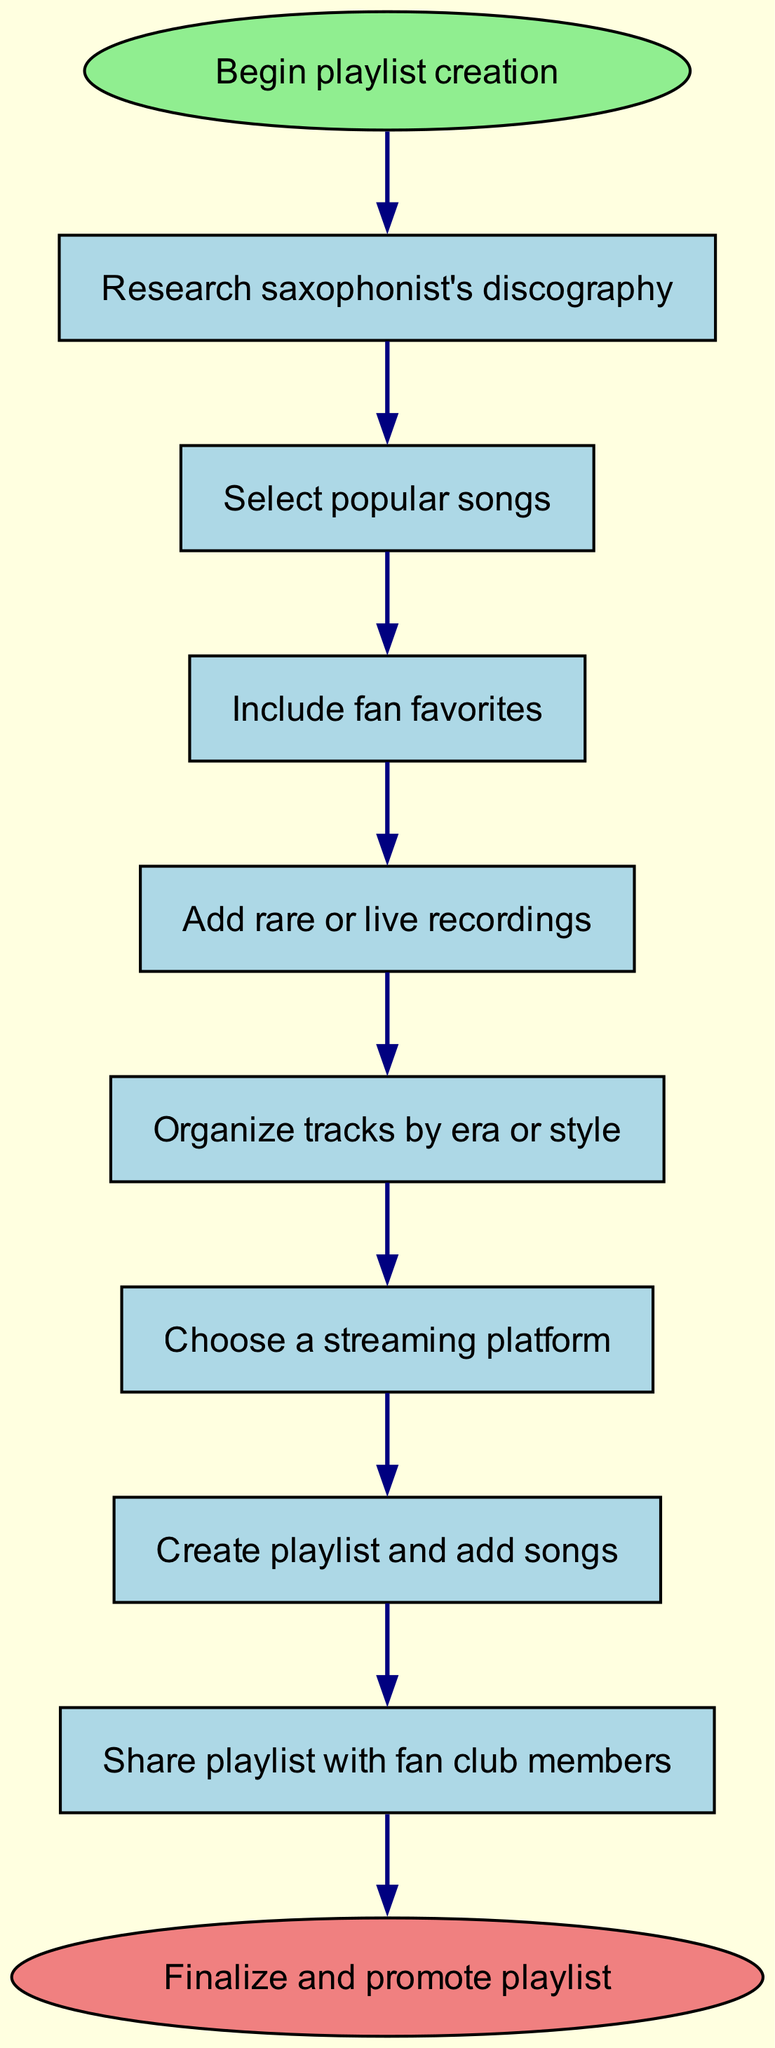What is the first step in creating the playlist? The first step is shown directly below the "Begin playlist creation" node and corresponds to the first action outlined in the flow chart. This is "Research saxophonist's discography".
Answer: Research saxophonist's discography How many steps are there in the creation process? Counting all the nodes representing steps in the flow chart, there are 8 distinct steps listed before reaching the end.
Answer: 8 What is the last step indicated in the flow chart? The terminal node of the flow chart indicates the final action to be taken after completing all previous steps. This is "Finalize and promote playlist".
Answer: Finalize and promote playlist Which step comes after "Include fan favorites"? Looking at the flow of the diagram, immediately following "Include fan favorites" is the step labeled "Add rare or live recordings".
Answer: Add rare or live recordings What type of songs should be added after selecting popular songs? By following the sequential connections in the flow chart, after the selection of popular songs, the next directive is to "Include fan favorites".
Answer: Include fan favorites How are the tracks organized in the playlist? The flow chart specifies that after adding songs, a step involves organizing tracks by "era or style", indicating how the arrangement is structured.
Answer: Era or style Which step is directly connected to "Choose a streaming platform"? By referencing the arrows in the flow chart, the step that precedes "Choose a streaming platform" is "Organize tracks by era or style".
Answer: Organize tracks by era or style What is the color of the start node in the flow chart? The start node is distinctly colored green, indicating its position as the initiation point in the flow process.
Answer: Light green 